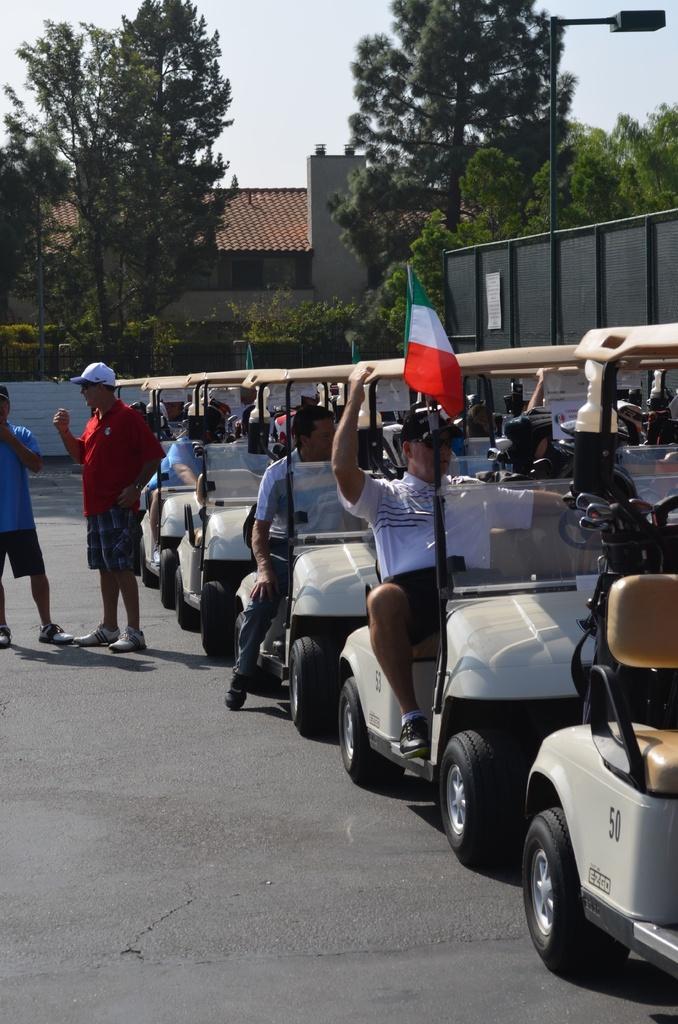Can you describe this image briefly? In the image we can see some vehicles on the road and two persons are standing. Behind them there is wall. Behind the wall there are some plants and trees and poles and building. At the top of the image there are some clouds and sky. 